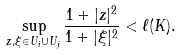Convert formula to latex. <formula><loc_0><loc_0><loc_500><loc_500>\sup _ { z , \xi \in U _ { i } \cup U _ { j } } \frac { 1 + | z | ^ { 2 } } { 1 + | \xi | ^ { 2 } } < \ell ( K ) .</formula> 